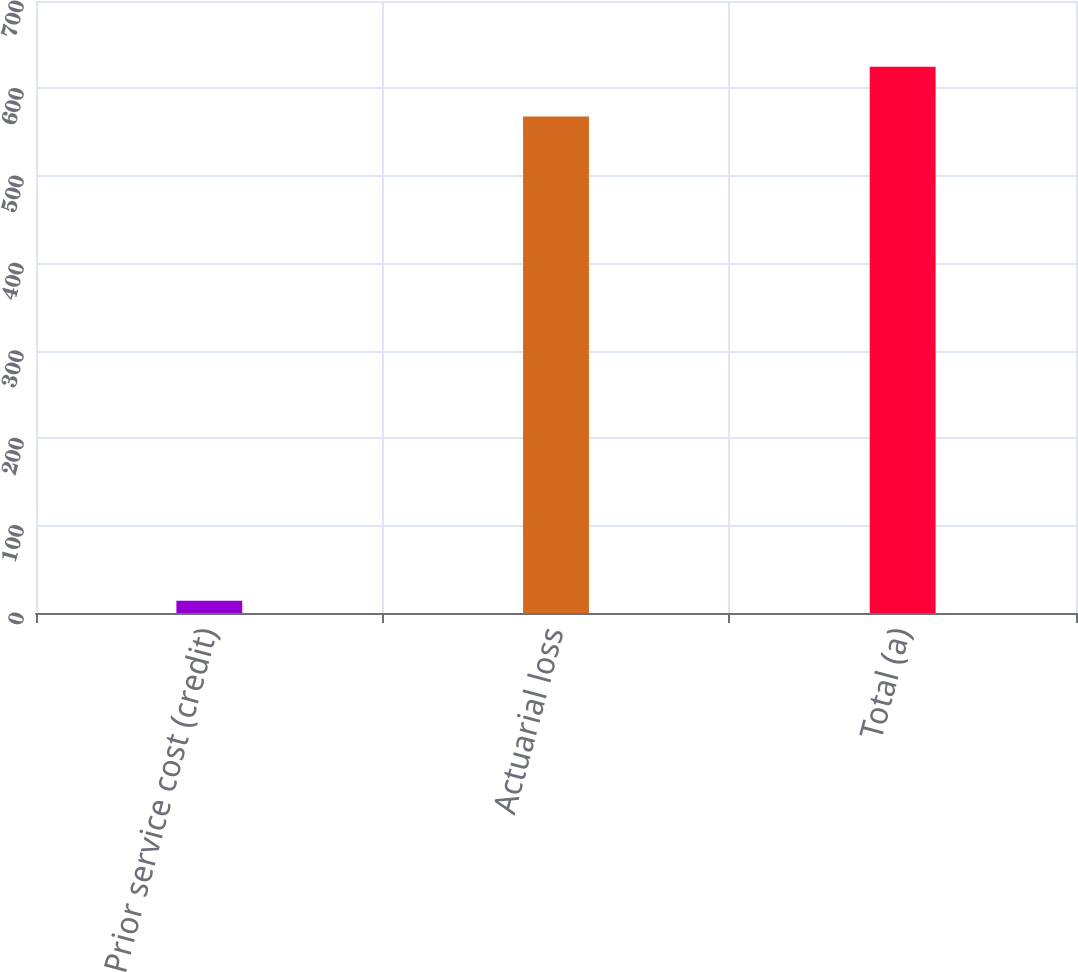Convert chart to OTSL. <chart><loc_0><loc_0><loc_500><loc_500><bar_chart><fcel>Prior service cost (credit)<fcel>Actuarial loss<fcel>Total (a)<nl><fcel>14<fcel>568<fcel>624.8<nl></chart> 